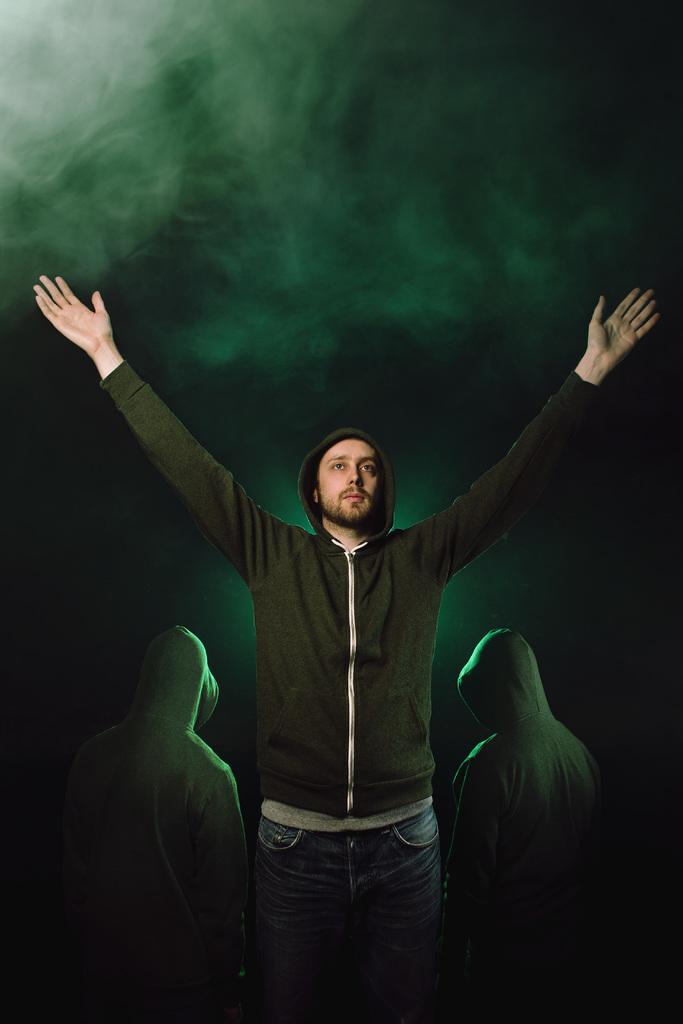What is the main subject of the image? The main subject of the image is a man standing with his hands spread out. Are there any other people in the image? Yes, there are two other persons standing beside the man. How would you describe the background of the image? The background of the image is dark and smokey. What type of bird can be seen flying in the image? There is no bird visible in the image; the focus is on the man and the two other persons. 